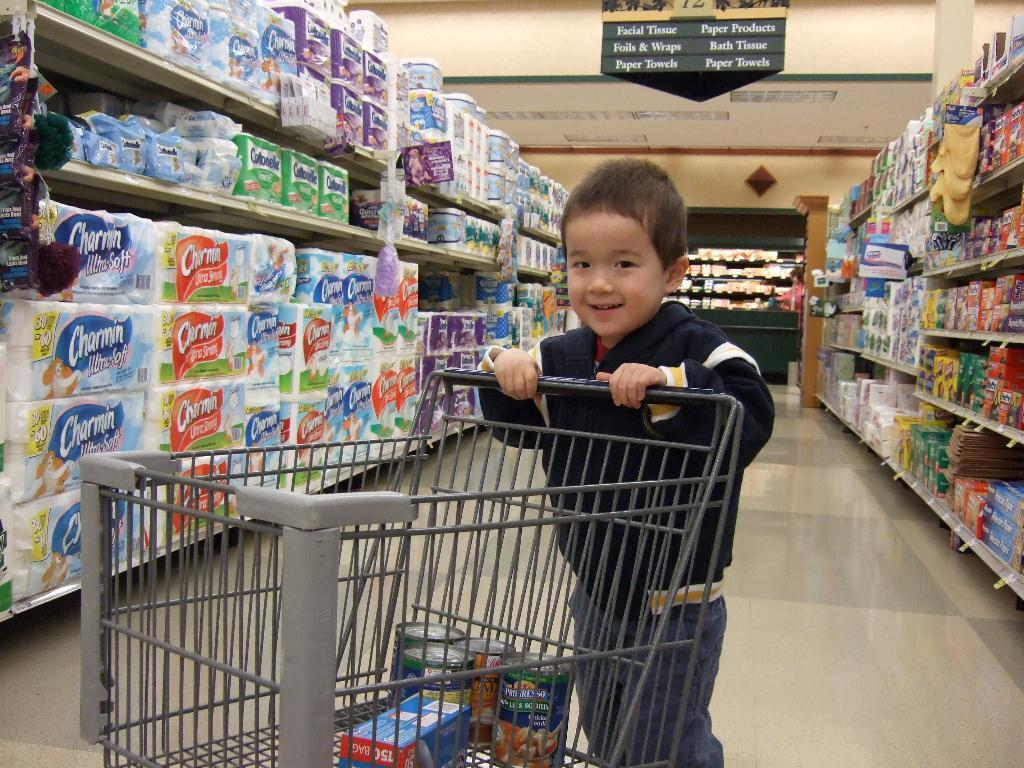<image>
Render a clear and concise summary of the photo. A child pushes a grocery cart next to Charmin toilet paper. 